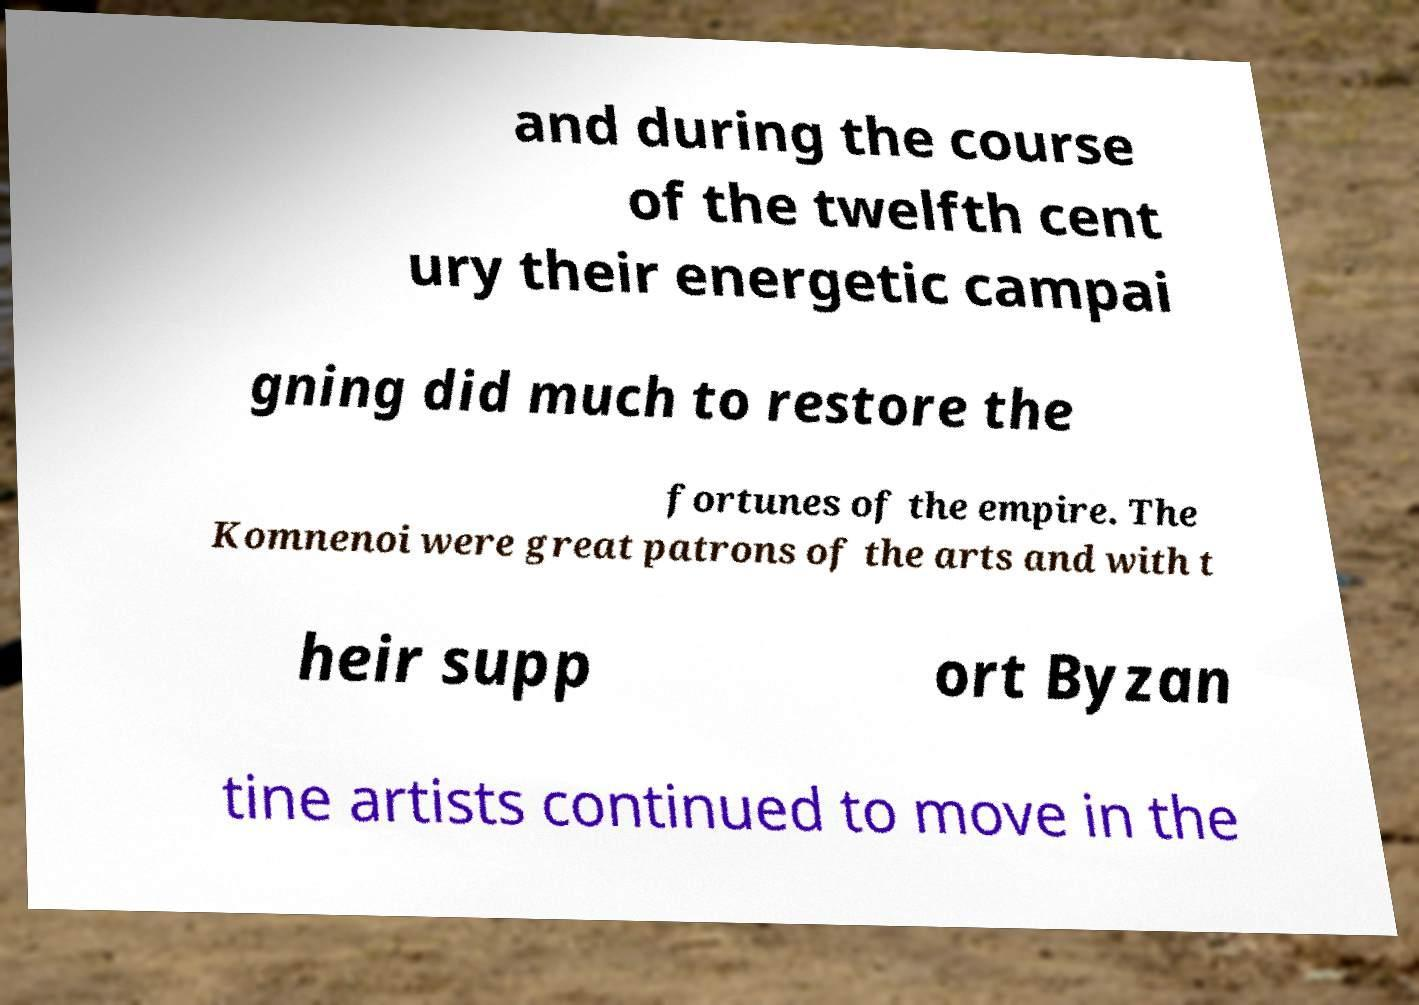Please read and relay the text visible in this image. What does it say? and during the course of the twelfth cent ury their energetic campai gning did much to restore the fortunes of the empire. The Komnenoi were great patrons of the arts and with t heir supp ort Byzan tine artists continued to move in the 